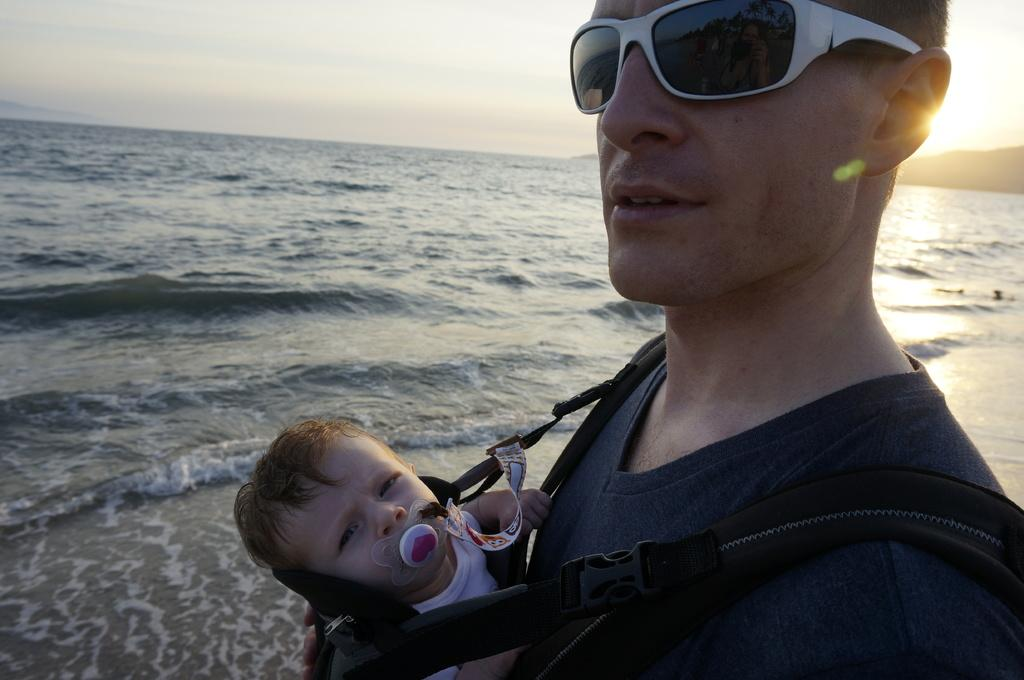What is the main subject of the image? There is a man in the image. What is the man wearing? The man is wearing a t-shirt and shades. What is the man doing in the image? The man is carrying a baby. What can be seen in the background of the image? Water and sky are visible in the background of the image. What celestial body is observable in the sky? The sun is observable in the sky. Where is the faucet located in the image? There is no faucet present in the image. What type of board is the man using to carry the baby? The man is not using a board to carry the baby; he is simply holding the baby in his arms. 